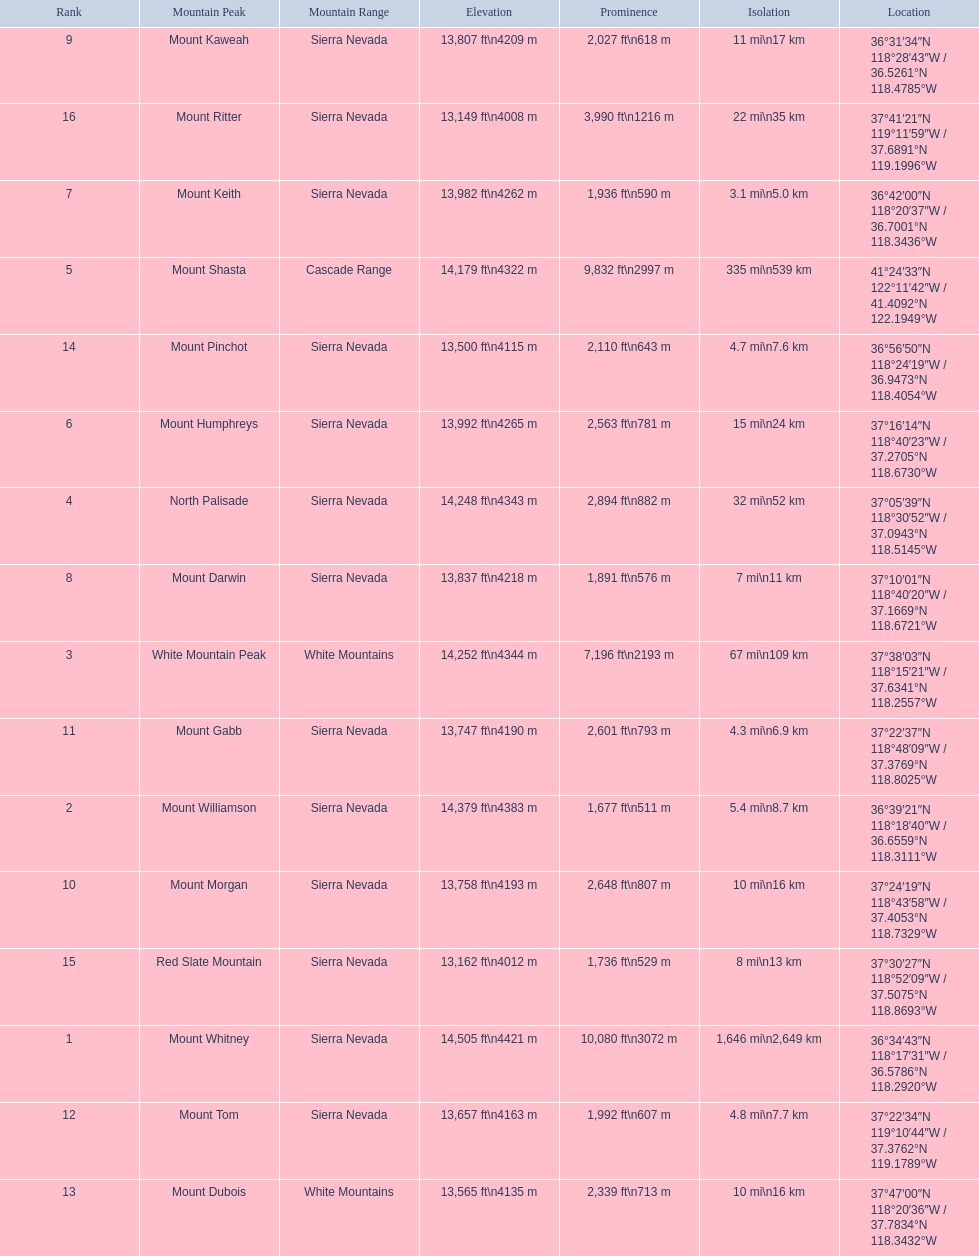Which mountain peak has the least isolation? Mount Keith. 